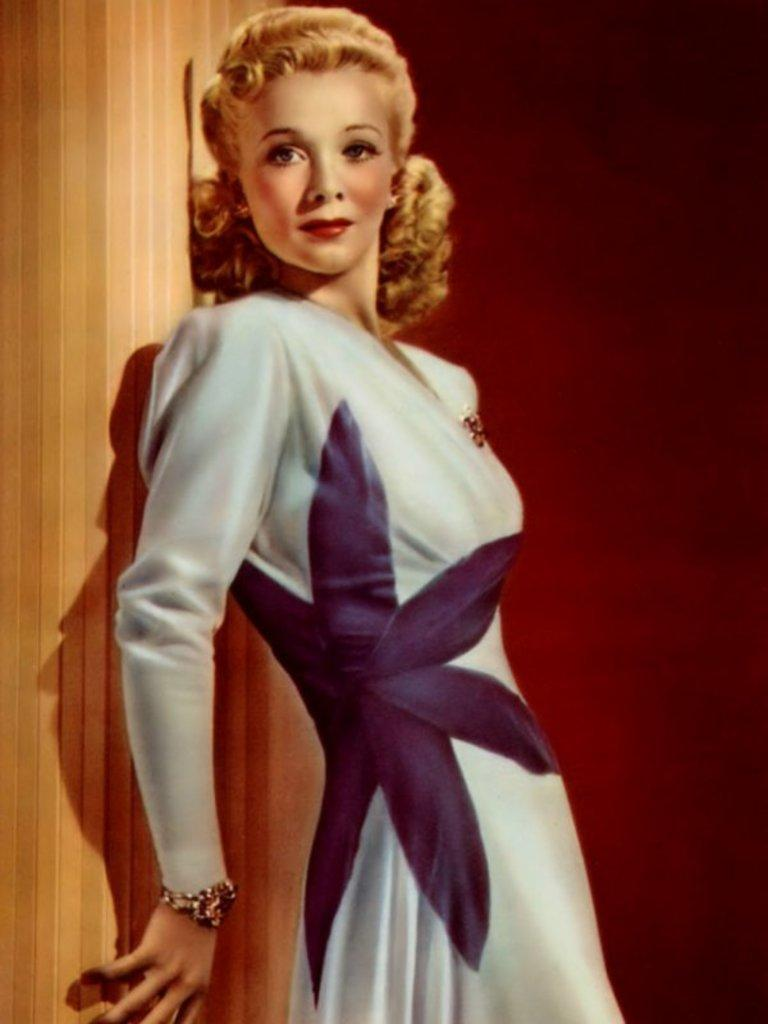What is the person in the image wearing? The person in the image is wearing a dress. What can be seen on the left side of the image? There is a brown color pillar on the left side of the image. What colors are present in the background of the image? The background of the image is black and maroon in color. How many children are visible in the image? There are no children present in the image. What type of bread is being used to support the person's elbow in the image? There is no bread or elbow support visible in the image. 